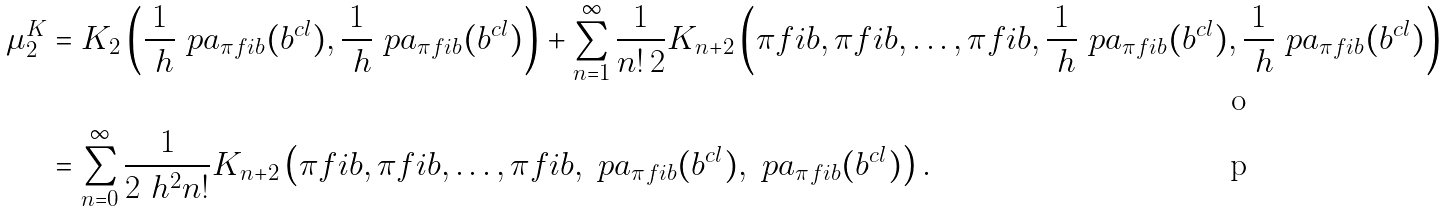Convert formula to latex. <formula><loc_0><loc_0><loc_500><loc_500>\mu ^ { K } _ { 2 } & = K _ { 2 } \left ( \frac { 1 } { \ h } \ p a _ { \pi f i b } ( b ^ { c l } ) , \frac { 1 } { \ h } \ p a _ { \pi f i b } ( b ^ { c l } ) \right ) + \sum _ { n = 1 } ^ { \infty } \frac { 1 } { n ! \, 2 } K _ { n + 2 } \left ( \pi f i b , \pi f i b , \dots , \pi f i b , \frac { 1 } { \ h } \ p a _ { \pi f i b } ( b ^ { c l } ) , \frac { 1 } { \ h } \ p a _ { \pi f i b } ( b ^ { c l } ) \right ) \\ & = \sum _ { n = 0 } ^ { \infty } \frac { 1 } { 2 \ h ^ { 2 } n ! } K _ { n + 2 } \left ( \pi f i b , \pi f i b , \dots , \pi f i b , \ p a _ { \pi f i b } ( b ^ { c l } ) , \ p a _ { \pi f i b } ( b ^ { c l } ) \right ) .</formula> 